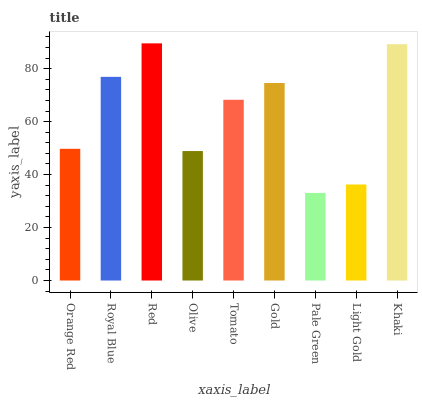Is Pale Green the minimum?
Answer yes or no. Yes. Is Red the maximum?
Answer yes or no. Yes. Is Royal Blue the minimum?
Answer yes or no. No. Is Royal Blue the maximum?
Answer yes or no. No. Is Royal Blue greater than Orange Red?
Answer yes or no. Yes. Is Orange Red less than Royal Blue?
Answer yes or no. Yes. Is Orange Red greater than Royal Blue?
Answer yes or no. No. Is Royal Blue less than Orange Red?
Answer yes or no. No. Is Tomato the high median?
Answer yes or no. Yes. Is Tomato the low median?
Answer yes or no. Yes. Is Red the high median?
Answer yes or no. No. Is Olive the low median?
Answer yes or no. No. 